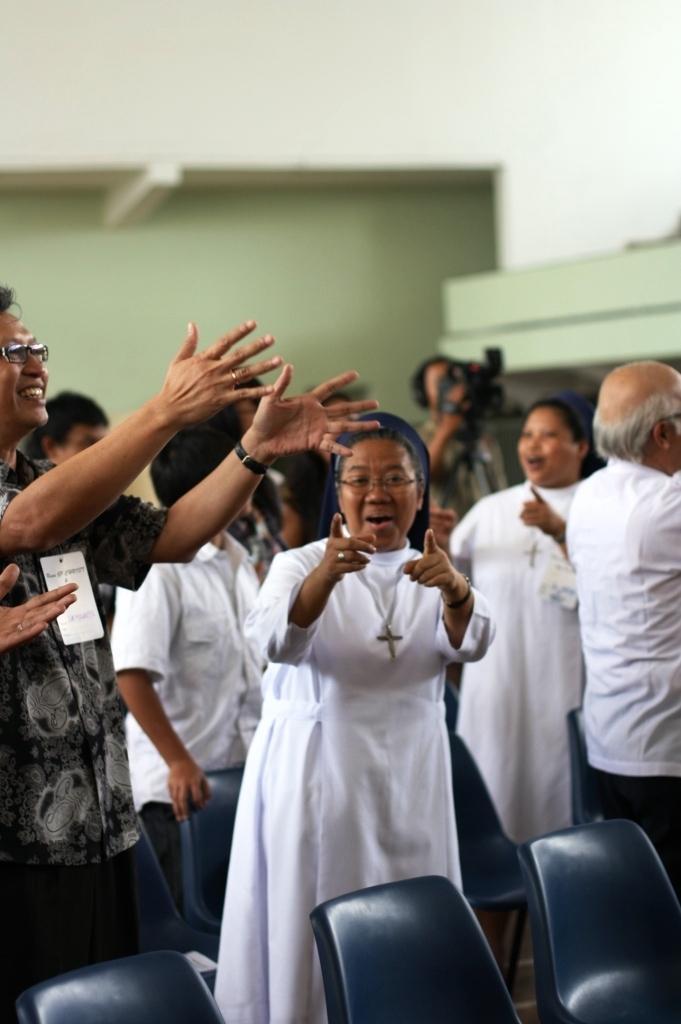In one or two sentences, can you explain what this image depicts? In this image I can see number of people are standing, I can also see smile on few faces. Here I can see few chairs. 